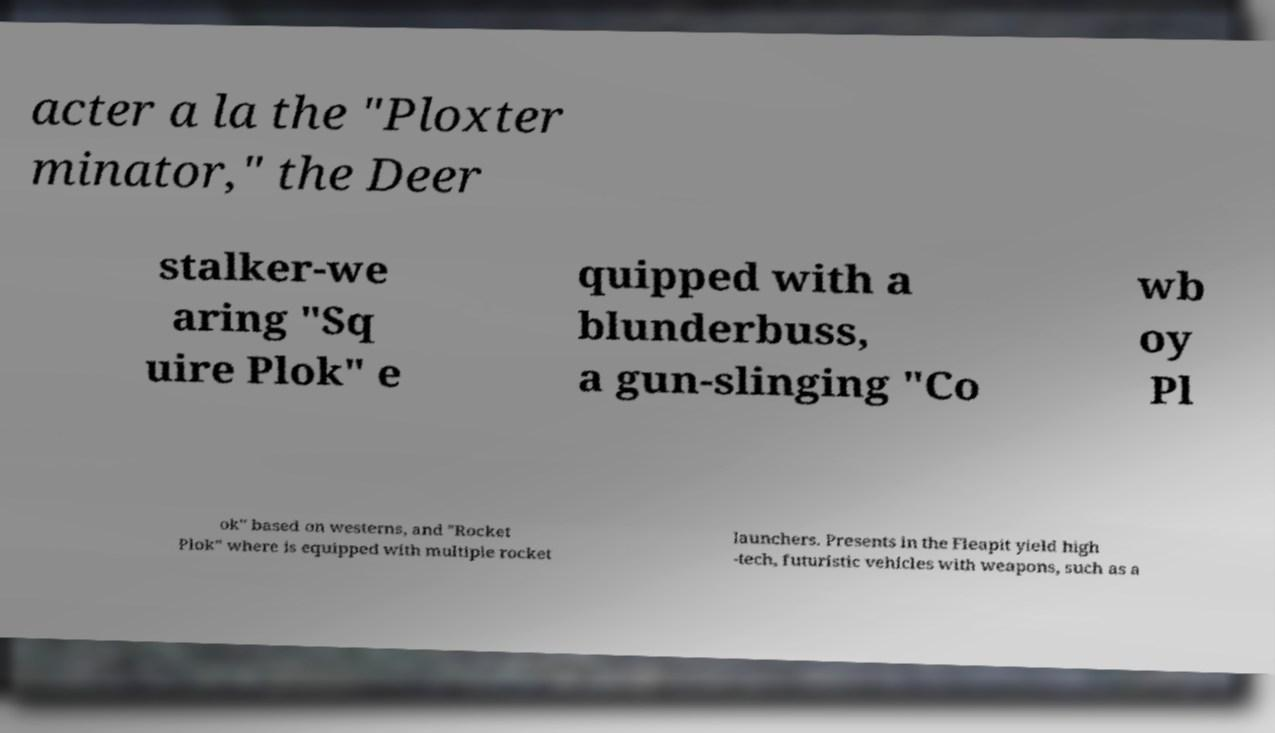Could you extract and type out the text from this image? acter a la the "Ploxter minator," the Deer stalker-we aring "Sq uire Plok" e quipped with a blunderbuss, a gun-slinging "Co wb oy Pl ok" based on westerns, and "Rocket Plok" where is equipped with multiple rocket launchers. Presents in the Fleapit yield high -tech, futuristic vehicles with weapons, such as a 